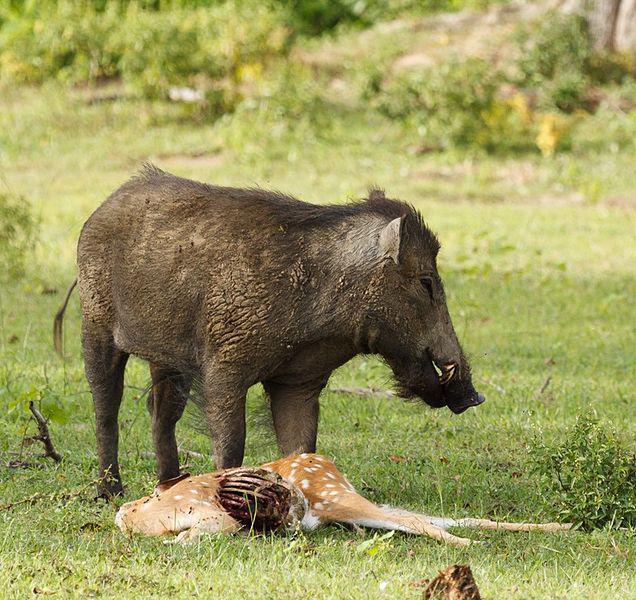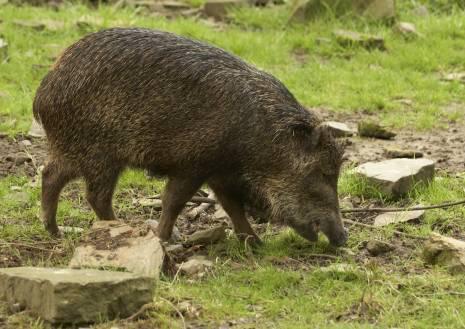The first image is the image on the left, the second image is the image on the right. For the images shown, is this caption "There are exactly two pigs." true? Answer yes or no. Yes. 